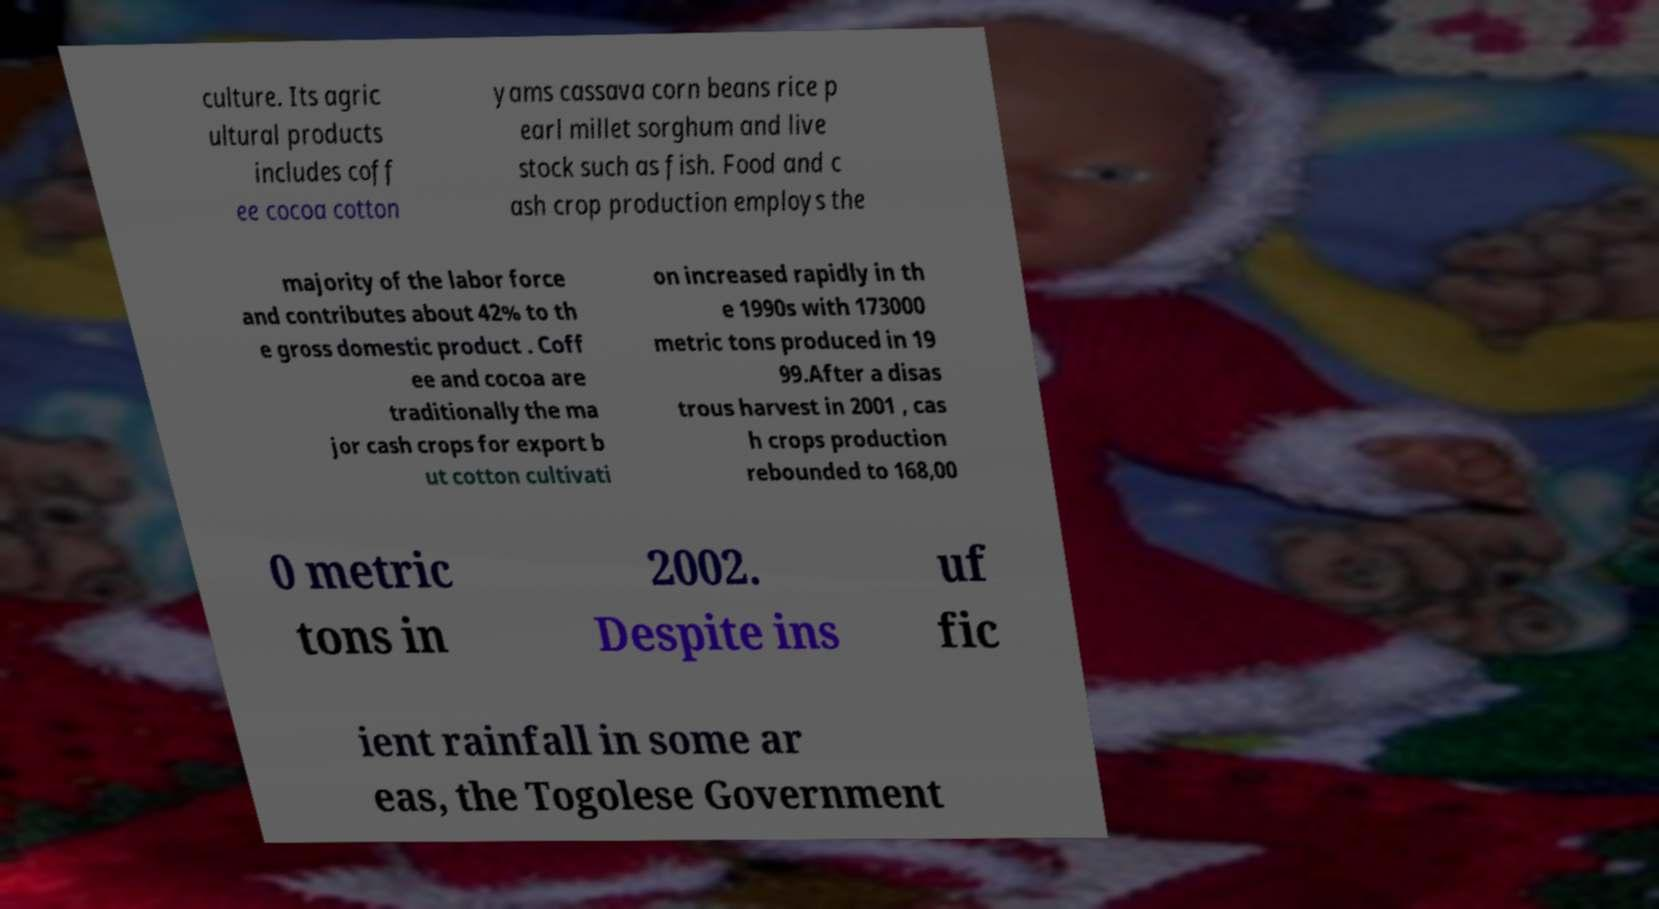Can you accurately transcribe the text from the provided image for me? culture. Its agric ultural products includes coff ee cocoa cotton yams cassava corn beans rice p earl millet sorghum and live stock such as fish. Food and c ash crop production employs the majority of the labor force and contributes about 42% to th e gross domestic product . Coff ee and cocoa are traditionally the ma jor cash crops for export b ut cotton cultivati on increased rapidly in th e 1990s with 173000 metric tons produced in 19 99.After a disas trous harvest in 2001 , cas h crops production rebounded to 168,00 0 metric tons in 2002. Despite ins uf fic ient rainfall in some ar eas, the Togolese Government 